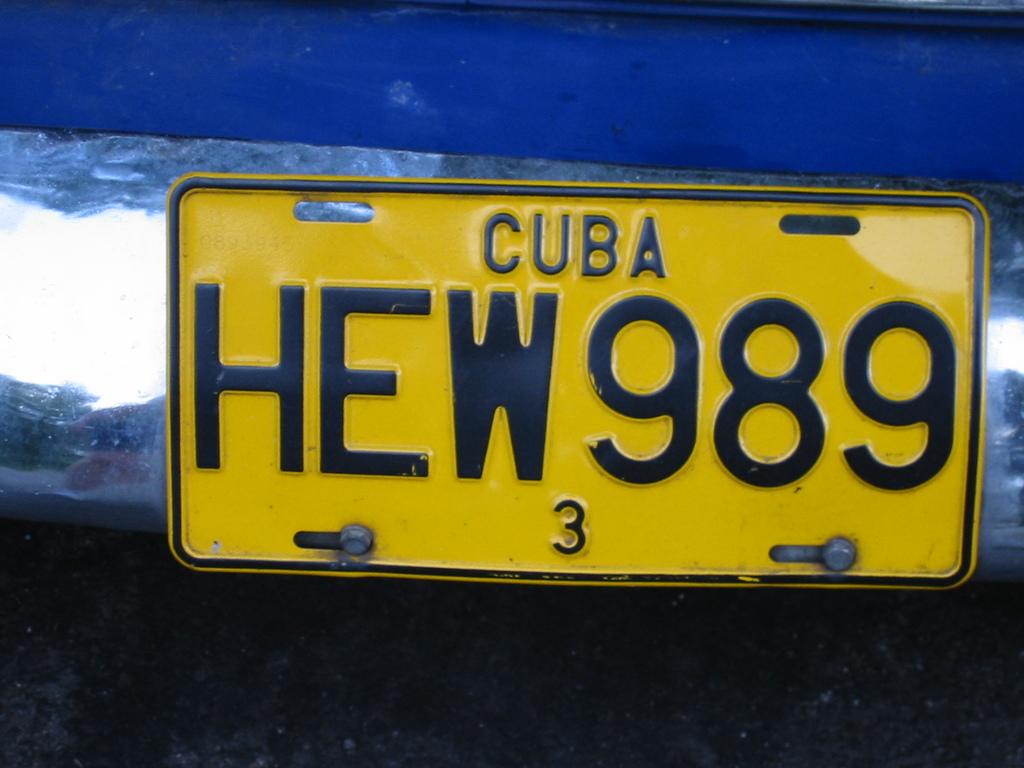Where was this licenses plate issued?
Your response must be concise. Cuba. What is the plate number?
Provide a succinct answer. Hew989. 